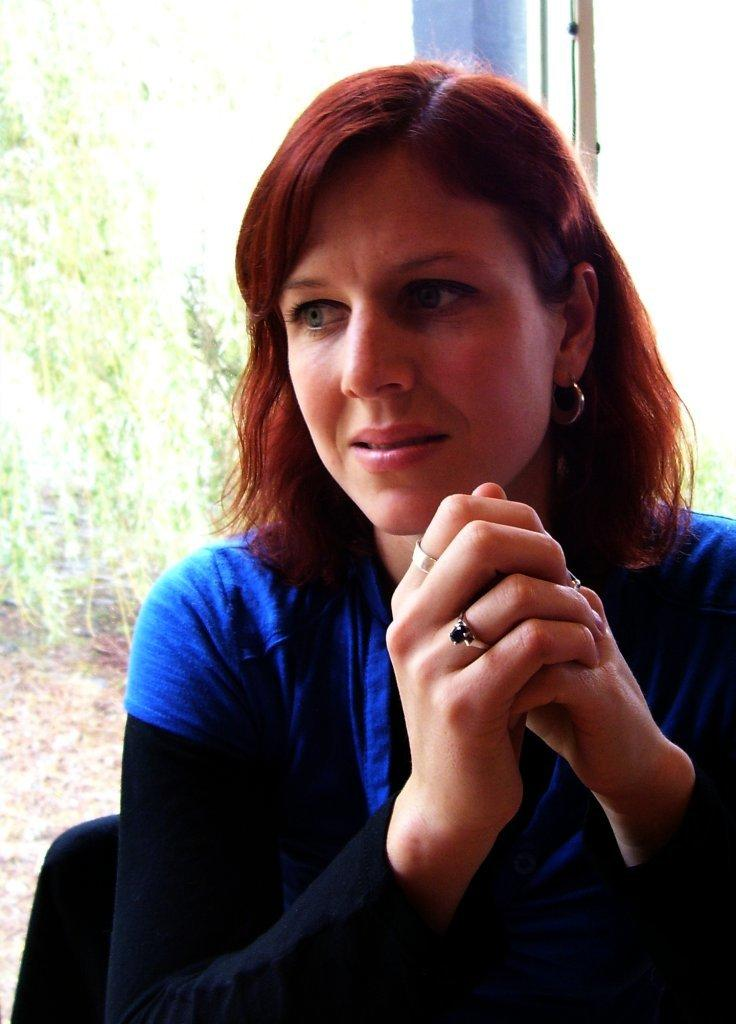What is the woman in the image doing? The woman is sitting on a chair in the image. In which direction is the woman looking? The woman is looking to the left side. What can be seen in the background of the image? There is a glass and plants in the background of the image. What type of cushion is the woman using to sit on the chair? The image does not provide information about a cushion on the chair, so it cannot be determined from the image. 